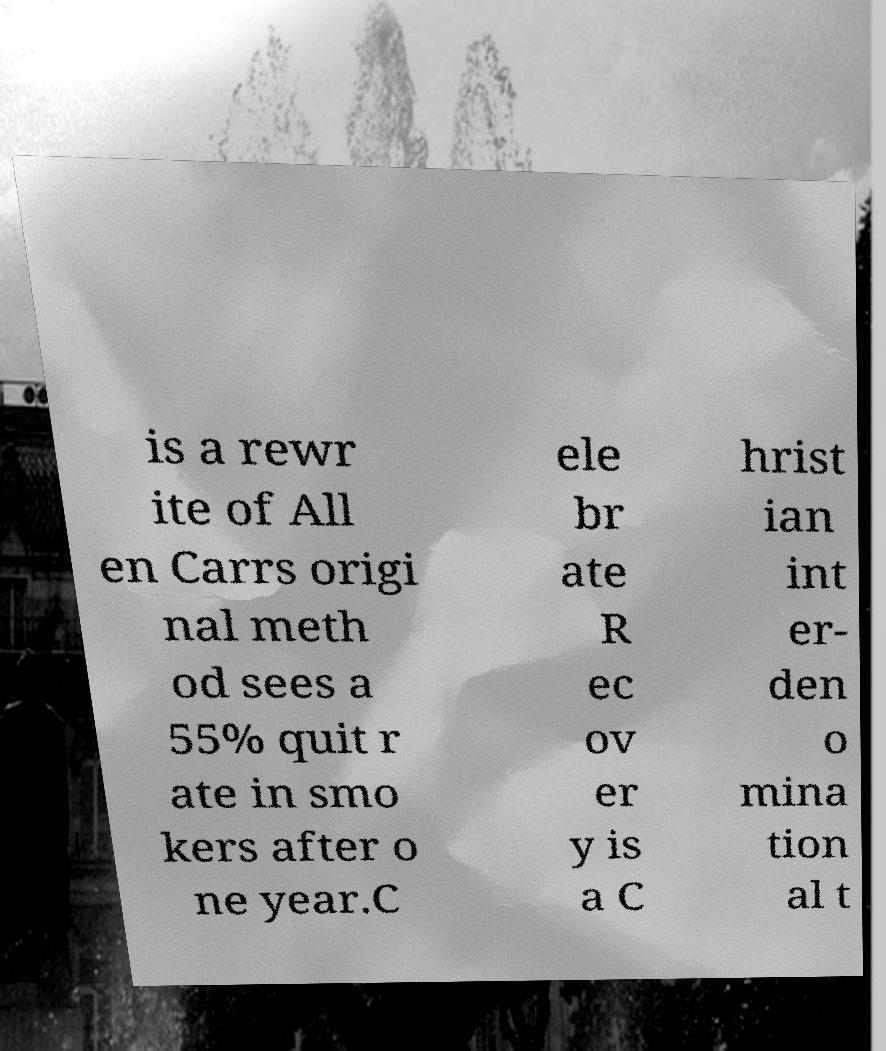Please identify and transcribe the text found in this image. is a rewr ite of All en Carrs origi nal meth od sees a 55% quit r ate in smo kers after o ne year.C ele br ate R ec ov er y is a C hrist ian int er- den o mina tion al t 